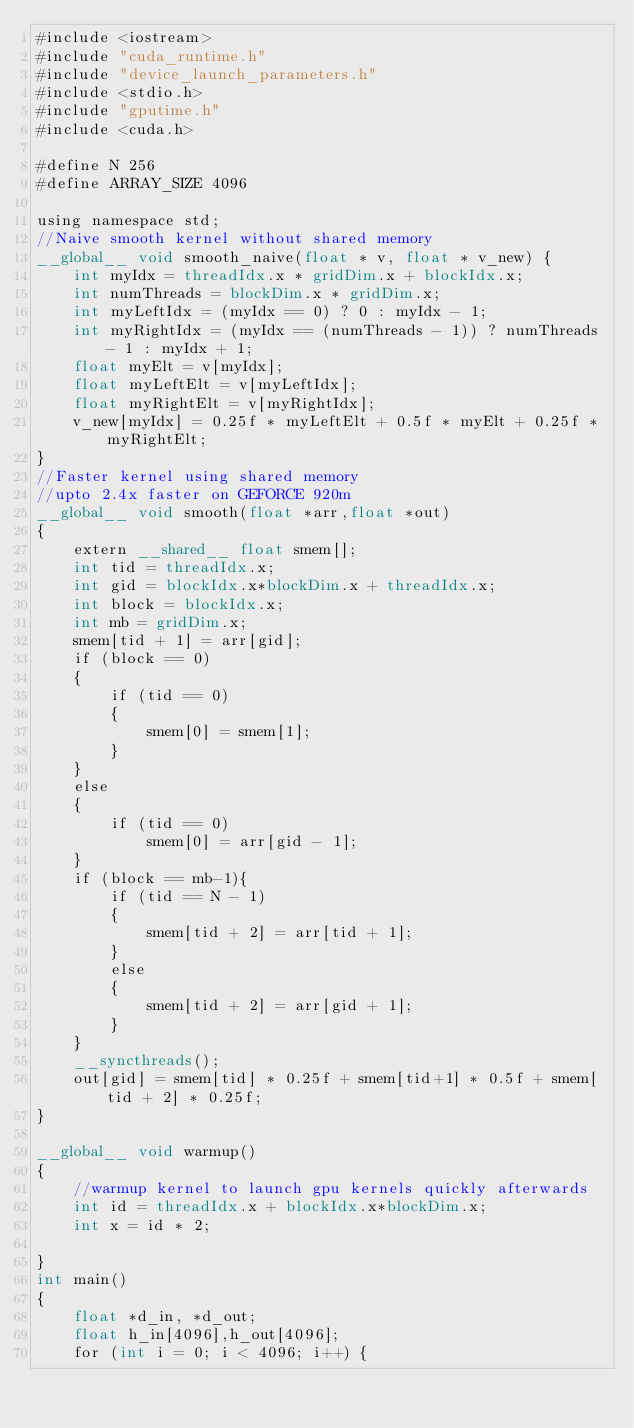<code> <loc_0><loc_0><loc_500><loc_500><_Cuda_>#include <iostream>
#include "cuda_runtime.h"
#include "device_launch_parameters.h"
#include <stdio.h>
#include "gputime.h"
#include <cuda.h>

#define N 256
#define ARRAY_SIZE 4096

using namespace std;
//Naive smooth kernel without shared memory
__global__ void smooth_naive(float * v, float * v_new) {
	int myIdx = threadIdx.x * gridDim.x + blockIdx.x;
	int numThreads = blockDim.x * gridDim.x;
	int myLeftIdx = (myIdx == 0) ? 0 : myIdx - 1;
	int myRightIdx = (myIdx == (numThreads - 1)) ? numThreads - 1 : myIdx + 1;
	float myElt = v[myIdx];
	float myLeftElt = v[myLeftIdx];
	float myRightElt = v[myRightIdx];
	v_new[myIdx] = 0.25f * myLeftElt + 0.5f * myElt + 0.25f * myRightElt;
}
//Faster kernel using shared memory 
//upto 2.4x faster on GEFORCE 920m
__global__ void smooth(float *arr,float *out)
{
	extern __shared__ float smem[];
	int tid = threadIdx.x;
	int gid = blockIdx.x*blockDim.x + threadIdx.x;
	int block = blockIdx.x;
	int mb = gridDim.x;
	smem[tid + 1] = arr[gid];
	if (block == 0)
	{
		if (tid == 0)
		{
			smem[0] = smem[1];
		}
	}
	else
	{
		if (tid == 0)
			smem[0] = arr[gid - 1];
	}
	if (block == mb-1){
		if (tid == N - 1)
		{
			smem[tid + 2] = arr[tid + 1];
		}
		else
		{
			smem[tid + 2] = arr[gid + 1];
		}
	}
	__syncthreads();
	out[gid] = smem[tid] * 0.25f + smem[tid+1] * 0.5f + smem[tid + 2] * 0.25f;
}

__global__ void warmup()
{
	//warmup kernel to launch gpu kernels quickly afterwards
	int id = threadIdx.x + blockIdx.x*blockDim.x;
	int x = id * 2;
	
}
int main()
{
	float *d_in, *d_out;
	float h_in[4096],h_out[4096];
	for (int i = 0; i < 4096; i++) {</code> 